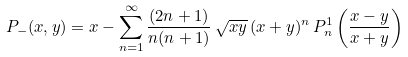<formula> <loc_0><loc_0><loc_500><loc_500>P _ { - } ( x , y ) = x - \sum _ { n = 1 } ^ { \infty } \frac { ( 2 n + 1 ) } { n ( n + 1 ) } \, \sqrt { x y } \, ( x + y ) ^ { n } \, P _ { n } ^ { 1 } \left ( \frac { x - y } { x + y } \right )</formula> 